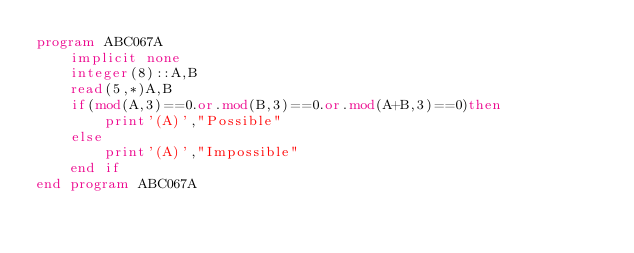Convert code to text. <code><loc_0><loc_0><loc_500><loc_500><_FORTRAN_>program ABC067A
    implicit none
    integer(8)::A,B
    read(5,*)A,B
    if(mod(A,3)==0.or.mod(B,3)==0.or.mod(A+B,3)==0)then
        print'(A)',"Possible"
    else
        print'(A)',"Impossible"
    end if
end program ABC067A</code> 